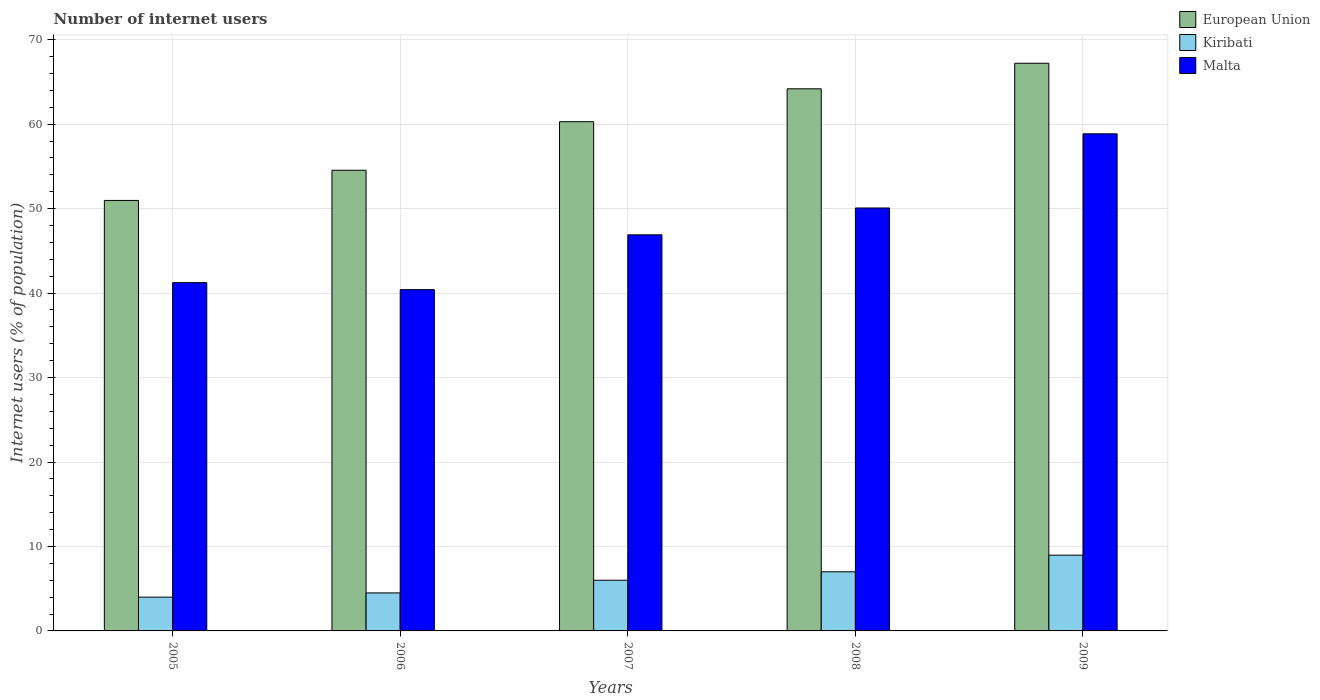Are the number of bars per tick equal to the number of legend labels?
Provide a short and direct response. Yes. Are the number of bars on each tick of the X-axis equal?
Provide a short and direct response. Yes. How many bars are there on the 3rd tick from the right?
Ensure brevity in your answer.  3. In how many cases, is the number of bars for a given year not equal to the number of legend labels?
Your answer should be compact. 0. What is the number of internet users in European Union in 2008?
Keep it short and to the point. 64.19. Across all years, what is the maximum number of internet users in Malta?
Ensure brevity in your answer.  58.86. Across all years, what is the minimum number of internet users in Malta?
Keep it short and to the point. 40.41. In which year was the number of internet users in Kiribati maximum?
Provide a short and direct response. 2009. In which year was the number of internet users in Kiribati minimum?
Offer a terse response. 2005. What is the total number of internet users in European Union in the graph?
Your answer should be compact. 297.22. What is the difference between the number of internet users in Malta in 2007 and that in 2008?
Provide a short and direct response. -3.18. What is the difference between the number of internet users in Malta in 2009 and the number of internet users in European Union in 2006?
Keep it short and to the point. 4.31. What is the average number of internet users in Malta per year?
Keep it short and to the point. 47.5. In the year 2006, what is the difference between the number of internet users in Malta and number of internet users in Kiribati?
Give a very brief answer. 35.91. In how many years, is the number of internet users in European Union greater than 10 %?
Provide a short and direct response. 5. What is the ratio of the number of internet users in European Union in 2007 to that in 2009?
Provide a short and direct response. 0.9. Is the number of internet users in Kiribati in 2007 less than that in 2008?
Keep it short and to the point. Yes. What is the difference between the highest and the second highest number of internet users in European Union?
Ensure brevity in your answer.  3.03. What is the difference between the highest and the lowest number of internet users in European Union?
Make the answer very short. 16.24. What does the 3rd bar from the left in 2006 represents?
Keep it short and to the point. Malta. What does the 2nd bar from the right in 2007 represents?
Give a very brief answer. Kiribati. Are all the bars in the graph horizontal?
Your answer should be compact. No. How many years are there in the graph?
Give a very brief answer. 5. What is the difference between two consecutive major ticks on the Y-axis?
Make the answer very short. 10. Does the graph contain any zero values?
Your answer should be compact. No. Where does the legend appear in the graph?
Your answer should be very brief. Top right. How many legend labels are there?
Give a very brief answer. 3. What is the title of the graph?
Your answer should be very brief. Number of internet users. What is the label or title of the Y-axis?
Offer a terse response. Internet users (% of population). What is the Internet users (% of population) of European Union in 2005?
Your response must be concise. 50.97. What is the Internet users (% of population) in Kiribati in 2005?
Provide a succinct answer. 4. What is the Internet users (% of population) in Malta in 2005?
Your response must be concise. 41.24. What is the Internet users (% of population) in European Union in 2006?
Give a very brief answer. 54.55. What is the Internet users (% of population) in Malta in 2006?
Ensure brevity in your answer.  40.41. What is the Internet users (% of population) of European Union in 2007?
Offer a very short reply. 60.3. What is the Internet users (% of population) in Malta in 2007?
Your answer should be very brief. 46.9. What is the Internet users (% of population) of European Union in 2008?
Your response must be concise. 64.19. What is the Internet users (% of population) in Malta in 2008?
Ensure brevity in your answer.  50.08. What is the Internet users (% of population) of European Union in 2009?
Your answer should be very brief. 67.21. What is the Internet users (% of population) of Kiribati in 2009?
Offer a very short reply. 8.97. What is the Internet users (% of population) of Malta in 2009?
Provide a succinct answer. 58.86. Across all years, what is the maximum Internet users (% of population) in European Union?
Provide a succinct answer. 67.21. Across all years, what is the maximum Internet users (% of population) of Kiribati?
Provide a succinct answer. 8.97. Across all years, what is the maximum Internet users (% of population) of Malta?
Make the answer very short. 58.86. Across all years, what is the minimum Internet users (% of population) of European Union?
Your answer should be very brief. 50.97. Across all years, what is the minimum Internet users (% of population) in Kiribati?
Make the answer very short. 4. Across all years, what is the minimum Internet users (% of population) of Malta?
Your answer should be very brief. 40.41. What is the total Internet users (% of population) of European Union in the graph?
Make the answer very short. 297.22. What is the total Internet users (% of population) in Kiribati in the graph?
Offer a terse response. 30.47. What is the total Internet users (% of population) in Malta in the graph?
Keep it short and to the point. 237.49. What is the difference between the Internet users (% of population) in European Union in 2005 and that in 2006?
Provide a short and direct response. -3.57. What is the difference between the Internet users (% of population) in Kiribati in 2005 and that in 2006?
Offer a terse response. -0.5. What is the difference between the Internet users (% of population) in Malta in 2005 and that in 2006?
Offer a terse response. 0.83. What is the difference between the Internet users (% of population) in European Union in 2005 and that in 2007?
Provide a succinct answer. -9.32. What is the difference between the Internet users (% of population) of Malta in 2005 and that in 2007?
Offer a very short reply. -5.66. What is the difference between the Internet users (% of population) of European Union in 2005 and that in 2008?
Provide a succinct answer. -13.22. What is the difference between the Internet users (% of population) of Kiribati in 2005 and that in 2008?
Provide a succinct answer. -3. What is the difference between the Internet users (% of population) in Malta in 2005 and that in 2008?
Provide a short and direct response. -8.84. What is the difference between the Internet users (% of population) in European Union in 2005 and that in 2009?
Your response must be concise. -16.24. What is the difference between the Internet users (% of population) in Kiribati in 2005 and that in 2009?
Your answer should be very brief. -4.97. What is the difference between the Internet users (% of population) of Malta in 2005 and that in 2009?
Give a very brief answer. -17.62. What is the difference between the Internet users (% of population) of European Union in 2006 and that in 2007?
Provide a short and direct response. -5.75. What is the difference between the Internet users (% of population) of Malta in 2006 and that in 2007?
Provide a short and direct response. -6.49. What is the difference between the Internet users (% of population) of European Union in 2006 and that in 2008?
Make the answer very short. -9.64. What is the difference between the Internet users (% of population) in Malta in 2006 and that in 2008?
Keep it short and to the point. -9.67. What is the difference between the Internet users (% of population) in European Union in 2006 and that in 2009?
Your response must be concise. -12.67. What is the difference between the Internet users (% of population) of Kiribati in 2006 and that in 2009?
Make the answer very short. -4.47. What is the difference between the Internet users (% of population) in Malta in 2006 and that in 2009?
Give a very brief answer. -18.45. What is the difference between the Internet users (% of population) in European Union in 2007 and that in 2008?
Provide a succinct answer. -3.89. What is the difference between the Internet users (% of population) in Kiribati in 2007 and that in 2008?
Give a very brief answer. -1. What is the difference between the Internet users (% of population) of Malta in 2007 and that in 2008?
Your response must be concise. -3.18. What is the difference between the Internet users (% of population) in European Union in 2007 and that in 2009?
Your answer should be compact. -6.92. What is the difference between the Internet users (% of population) in Kiribati in 2007 and that in 2009?
Make the answer very short. -2.97. What is the difference between the Internet users (% of population) of Malta in 2007 and that in 2009?
Keep it short and to the point. -11.96. What is the difference between the Internet users (% of population) of European Union in 2008 and that in 2009?
Make the answer very short. -3.03. What is the difference between the Internet users (% of population) in Kiribati in 2008 and that in 2009?
Keep it short and to the point. -1.97. What is the difference between the Internet users (% of population) in Malta in 2008 and that in 2009?
Make the answer very short. -8.78. What is the difference between the Internet users (% of population) in European Union in 2005 and the Internet users (% of population) in Kiribati in 2006?
Give a very brief answer. 46.47. What is the difference between the Internet users (% of population) in European Union in 2005 and the Internet users (% of population) in Malta in 2006?
Provide a short and direct response. 10.56. What is the difference between the Internet users (% of population) of Kiribati in 2005 and the Internet users (% of population) of Malta in 2006?
Provide a short and direct response. -36.41. What is the difference between the Internet users (% of population) in European Union in 2005 and the Internet users (% of population) in Kiribati in 2007?
Make the answer very short. 44.97. What is the difference between the Internet users (% of population) of European Union in 2005 and the Internet users (% of population) of Malta in 2007?
Offer a very short reply. 4.07. What is the difference between the Internet users (% of population) of Kiribati in 2005 and the Internet users (% of population) of Malta in 2007?
Make the answer very short. -42.9. What is the difference between the Internet users (% of population) of European Union in 2005 and the Internet users (% of population) of Kiribati in 2008?
Give a very brief answer. 43.97. What is the difference between the Internet users (% of population) of European Union in 2005 and the Internet users (% of population) of Malta in 2008?
Ensure brevity in your answer.  0.89. What is the difference between the Internet users (% of population) in Kiribati in 2005 and the Internet users (% of population) in Malta in 2008?
Keep it short and to the point. -46.08. What is the difference between the Internet users (% of population) in European Union in 2005 and the Internet users (% of population) in Kiribati in 2009?
Keep it short and to the point. 42. What is the difference between the Internet users (% of population) in European Union in 2005 and the Internet users (% of population) in Malta in 2009?
Provide a short and direct response. -7.89. What is the difference between the Internet users (% of population) of Kiribati in 2005 and the Internet users (% of population) of Malta in 2009?
Provide a succinct answer. -54.86. What is the difference between the Internet users (% of population) of European Union in 2006 and the Internet users (% of population) of Kiribati in 2007?
Keep it short and to the point. 48.55. What is the difference between the Internet users (% of population) in European Union in 2006 and the Internet users (% of population) in Malta in 2007?
Offer a terse response. 7.65. What is the difference between the Internet users (% of population) of Kiribati in 2006 and the Internet users (% of population) of Malta in 2007?
Provide a succinct answer. -42.4. What is the difference between the Internet users (% of population) of European Union in 2006 and the Internet users (% of population) of Kiribati in 2008?
Give a very brief answer. 47.55. What is the difference between the Internet users (% of population) in European Union in 2006 and the Internet users (% of population) in Malta in 2008?
Ensure brevity in your answer.  4.47. What is the difference between the Internet users (% of population) in Kiribati in 2006 and the Internet users (% of population) in Malta in 2008?
Provide a succinct answer. -45.58. What is the difference between the Internet users (% of population) in European Union in 2006 and the Internet users (% of population) in Kiribati in 2009?
Your answer should be very brief. 45.58. What is the difference between the Internet users (% of population) in European Union in 2006 and the Internet users (% of population) in Malta in 2009?
Provide a succinct answer. -4.31. What is the difference between the Internet users (% of population) of Kiribati in 2006 and the Internet users (% of population) of Malta in 2009?
Make the answer very short. -54.36. What is the difference between the Internet users (% of population) of European Union in 2007 and the Internet users (% of population) of Kiribati in 2008?
Provide a short and direct response. 53.3. What is the difference between the Internet users (% of population) of European Union in 2007 and the Internet users (% of population) of Malta in 2008?
Make the answer very short. 10.22. What is the difference between the Internet users (% of population) in Kiribati in 2007 and the Internet users (% of population) in Malta in 2008?
Provide a short and direct response. -44.08. What is the difference between the Internet users (% of population) in European Union in 2007 and the Internet users (% of population) in Kiribati in 2009?
Offer a very short reply. 51.33. What is the difference between the Internet users (% of population) in European Union in 2007 and the Internet users (% of population) in Malta in 2009?
Offer a very short reply. 1.44. What is the difference between the Internet users (% of population) in Kiribati in 2007 and the Internet users (% of population) in Malta in 2009?
Offer a very short reply. -52.86. What is the difference between the Internet users (% of population) in European Union in 2008 and the Internet users (% of population) in Kiribati in 2009?
Your response must be concise. 55.22. What is the difference between the Internet users (% of population) of European Union in 2008 and the Internet users (% of population) of Malta in 2009?
Your answer should be very brief. 5.33. What is the difference between the Internet users (% of population) in Kiribati in 2008 and the Internet users (% of population) in Malta in 2009?
Ensure brevity in your answer.  -51.86. What is the average Internet users (% of population) of European Union per year?
Ensure brevity in your answer.  59.44. What is the average Internet users (% of population) in Kiribati per year?
Keep it short and to the point. 6.09. What is the average Internet users (% of population) in Malta per year?
Keep it short and to the point. 47.5. In the year 2005, what is the difference between the Internet users (% of population) of European Union and Internet users (% of population) of Kiribati?
Ensure brevity in your answer.  46.97. In the year 2005, what is the difference between the Internet users (% of population) of European Union and Internet users (% of population) of Malta?
Provide a succinct answer. 9.73. In the year 2005, what is the difference between the Internet users (% of population) of Kiribati and Internet users (% of population) of Malta?
Ensure brevity in your answer.  -37.24. In the year 2006, what is the difference between the Internet users (% of population) of European Union and Internet users (% of population) of Kiribati?
Offer a terse response. 50.05. In the year 2006, what is the difference between the Internet users (% of population) of European Union and Internet users (% of population) of Malta?
Provide a short and direct response. 14.14. In the year 2006, what is the difference between the Internet users (% of population) in Kiribati and Internet users (% of population) in Malta?
Offer a very short reply. -35.91. In the year 2007, what is the difference between the Internet users (% of population) of European Union and Internet users (% of population) of Kiribati?
Your response must be concise. 54.3. In the year 2007, what is the difference between the Internet users (% of population) in European Union and Internet users (% of population) in Malta?
Give a very brief answer. 13.4. In the year 2007, what is the difference between the Internet users (% of population) in Kiribati and Internet users (% of population) in Malta?
Make the answer very short. -40.9. In the year 2008, what is the difference between the Internet users (% of population) of European Union and Internet users (% of population) of Kiribati?
Make the answer very short. 57.19. In the year 2008, what is the difference between the Internet users (% of population) of European Union and Internet users (% of population) of Malta?
Make the answer very short. 14.11. In the year 2008, what is the difference between the Internet users (% of population) in Kiribati and Internet users (% of population) in Malta?
Ensure brevity in your answer.  -43.08. In the year 2009, what is the difference between the Internet users (% of population) in European Union and Internet users (% of population) in Kiribati?
Ensure brevity in your answer.  58.24. In the year 2009, what is the difference between the Internet users (% of population) of European Union and Internet users (% of population) of Malta?
Ensure brevity in your answer.  8.35. In the year 2009, what is the difference between the Internet users (% of population) in Kiribati and Internet users (% of population) in Malta?
Make the answer very short. -49.89. What is the ratio of the Internet users (% of population) of European Union in 2005 to that in 2006?
Provide a short and direct response. 0.93. What is the ratio of the Internet users (% of population) of Malta in 2005 to that in 2006?
Make the answer very short. 1.02. What is the ratio of the Internet users (% of population) in European Union in 2005 to that in 2007?
Ensure brevity in your answer.  0.85. What is the ratio of the Internet users (% of population) of Kiribati in 2005 to that in 2007?
Ensure brevity in your answer.  0.67. What is the ratio of the Internet users (% of population) of Malta in 2005 to that in 2007?
Ensure brevity in your answer.  0.88. What is the ratio of the Internet users (% of population) in European Union in 2005 to that in 2008?
Provide a succinct answer. 0.79. What is the ratio of the Internet users (% of population) in Kiribati in 2005 to that in 2008?
Keep it short and to the point. 0.57. What is the ratio of the Internet users (% of population) in Malta in 2005 to that in 2008?
Provide a short and direct response. 0.82. What is the ratio of the Internet users (% of population) in European Union in 2005 to that in 2009?
Provide a succinct answer. 0.76. What is the ratio of the Internet users (% of population) of Kiribati in 2005 to that in 2009?
Ensure brevity in your answer.  0.45. What is the ratio of the Internet users (% of population) in Malta in 2005 to that in 2009?
Keep it short and to the point. 0.7. What is the ratio of the Internet users (% of population) of European Union in 2006 to that in 2007?
Provide a short and direct response. 0.9. What is the ratio of the Internet users (% of population) of Kiribati in 2006 to that in 2007?
Your answer should be very brief. 0.75. What is the ratio of the Internet users (% of population) of Malta in 2006 to that in 2007?
Your answer should be compact. 0.86. What is the ratio of the Internet users (% of population) of European Union in 2006 to that in 2008?
Give a very brief answer. 0.85. What is the ratio of the Internet users (% of population) of Kiribati in 2006 to that in 2008?
Offer a very short reply. 0.64. What is the ratio of the Internet users (% of population) in Malta in 2006 to that in 2008?
Your answer should be very brief. 0.81. What is the ratio of the Internet users (% of population) in European Union in 2006 to that in 2009?
Ensure brevity in your answer.  0.81. What is the ratio of the Internet users (% of population) in Kiribati in 2006 to that in 2009?
Keep it short and to the point. 0.5. What is the ratio of the Internet users (% of population) of Malta in 2006 to that in 2009?
Keep it short and to the point. 0.69. What is the ratio of the Internet users (% of population) of European Union in 2007 to that in 2008?
Provide a succinct answer. 0.94. What is the ratio of the Internet users (% of population) in Malta in 2007 to that in 2008?
Offer a very short reply. 0.94. What is the ratio of the Internet users (% of population) in European Union in 2007 to that in 2009?
Provide a short and direct response. 0.9. What is the ratio of the Internet users (% of population) of Kiribati in 2007 to that in 2009?
Provide a short and direct response. 0.67. What is the ratio of the Internet users (% of population) in Malta in 2007 to that in 2009?
Offer a terse response. 0.8. What is the ratio of the Internet users (% of population) of European Union in 2008 to that in 2009?
Provide a short and direct response. 0.95. What is the ratio of the Internet users (% of population) in Kiribati in 2008 to that in 2009?
Keep it short and to the point. 0.78. What is the ratio of the Internet users (% of population) in Malta in 2008 to that in 2009?
Make the answer very short. 0.85. What is the difference between the highest and the second highest Internet users (% of population) of European Union?
Keep it short and to the point. 3.03. What is the difference between the highest and the second highest Internet users (% of population) of Kiribati?
Your answer should be very brief. 1.97. What is the difference between the highest and the second highest Internet users (% of population) of Malta?
Make the answer very short. 8.78. What is the difference between the highest and the lowest Internet users (% of population) in European Union?
Your answer should be compact. 16.24. What is the difference between the highest and the lowest Internet users (% of population) in Kiribati?
Keep it short and to the point. 4.97. What is the difference between the highest and the lowest Internet users (% of population) in Malta?
Ensure brevity in your answer.  18.45. 